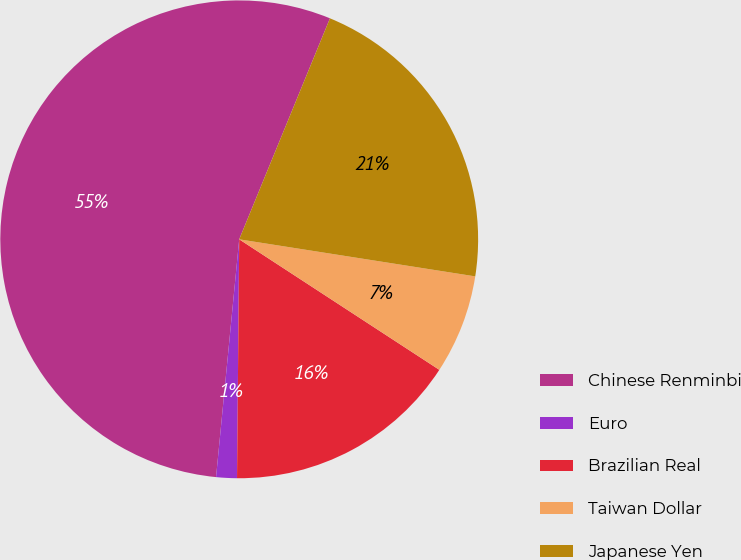<chart> <loc_0><loc_0><loc_500><loc_500><pie_chart><fcel>Chinese Renminbi<fcel>Euro<fcel>Brazilian Real<fcel>Taiwan Dollar<fcel>Japanese Yen<nl><fcel>54.66%<fcel>1.4%<fcel>15.95%<fcel>6.72%<fcel>21.28%<nl></chart> 